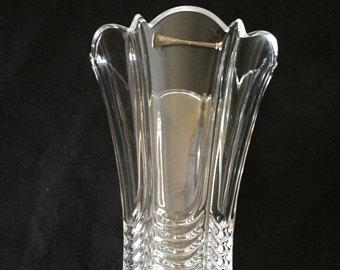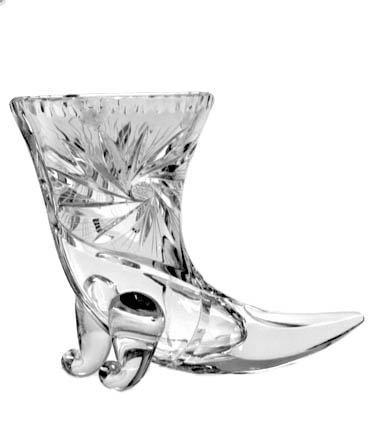The first image is the image on the left, the second image is the image on the right. Analyze the images presented: Is the assertion "There is exactly one curved glass vase is shown in every photograph and in every photo the entire vase is visible." valid? Answer yes or no. No. 